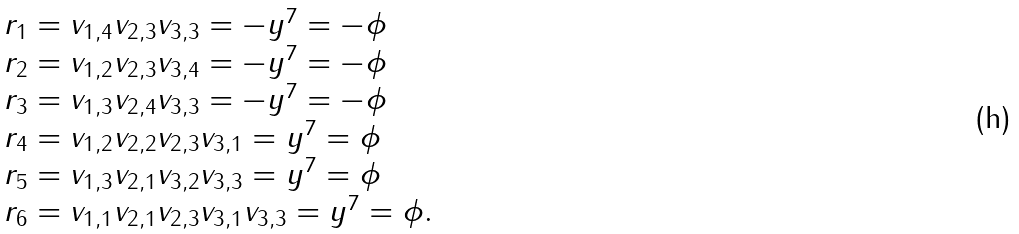Convert formula to latex. <formula><loc_0><loc_0><loc_500><loc_500>\begin{array} { l } r _ { 1 } = v _ { 1 , 4 } v _ { 2 , 3 } v _ { 3 , 3 } = - y ^ { 7 } = - \phi \\ r _ { 2 } = v _ { 1 , 2 } v _ { 2 , 3 } v _ { 3 , 4 } = - y ^ { 7 } = - \phi \\ r _ { 3 } = v _ { 1 , 3 } v _ { 2 , 4 } v _ { 3 , 3 } = - y ^ { 7 } = - \phi \\ r _ { 4 } = v _ { 1 , 2 } v _ { 2 , 2 } v _ { 2 , 3 } v _ { 3 , 1 } = y ^ { 7 } = \phi \\ r _ { 5 } = v _ { 1 , 3 } v _ { 2 , 1 } v _ { 3 , 2 } v _ { 3 , 3 } = y ^ { 7 } = \phi \\ r _ { 6 } = v _ { 1 , 1 } v _ { 2 , 1 } v _ { 2 , 3 } v _ { 3 , 1 } v _ { 3 , 3 } = y ^ { 7 } = \phi . \end{array}</formula> 